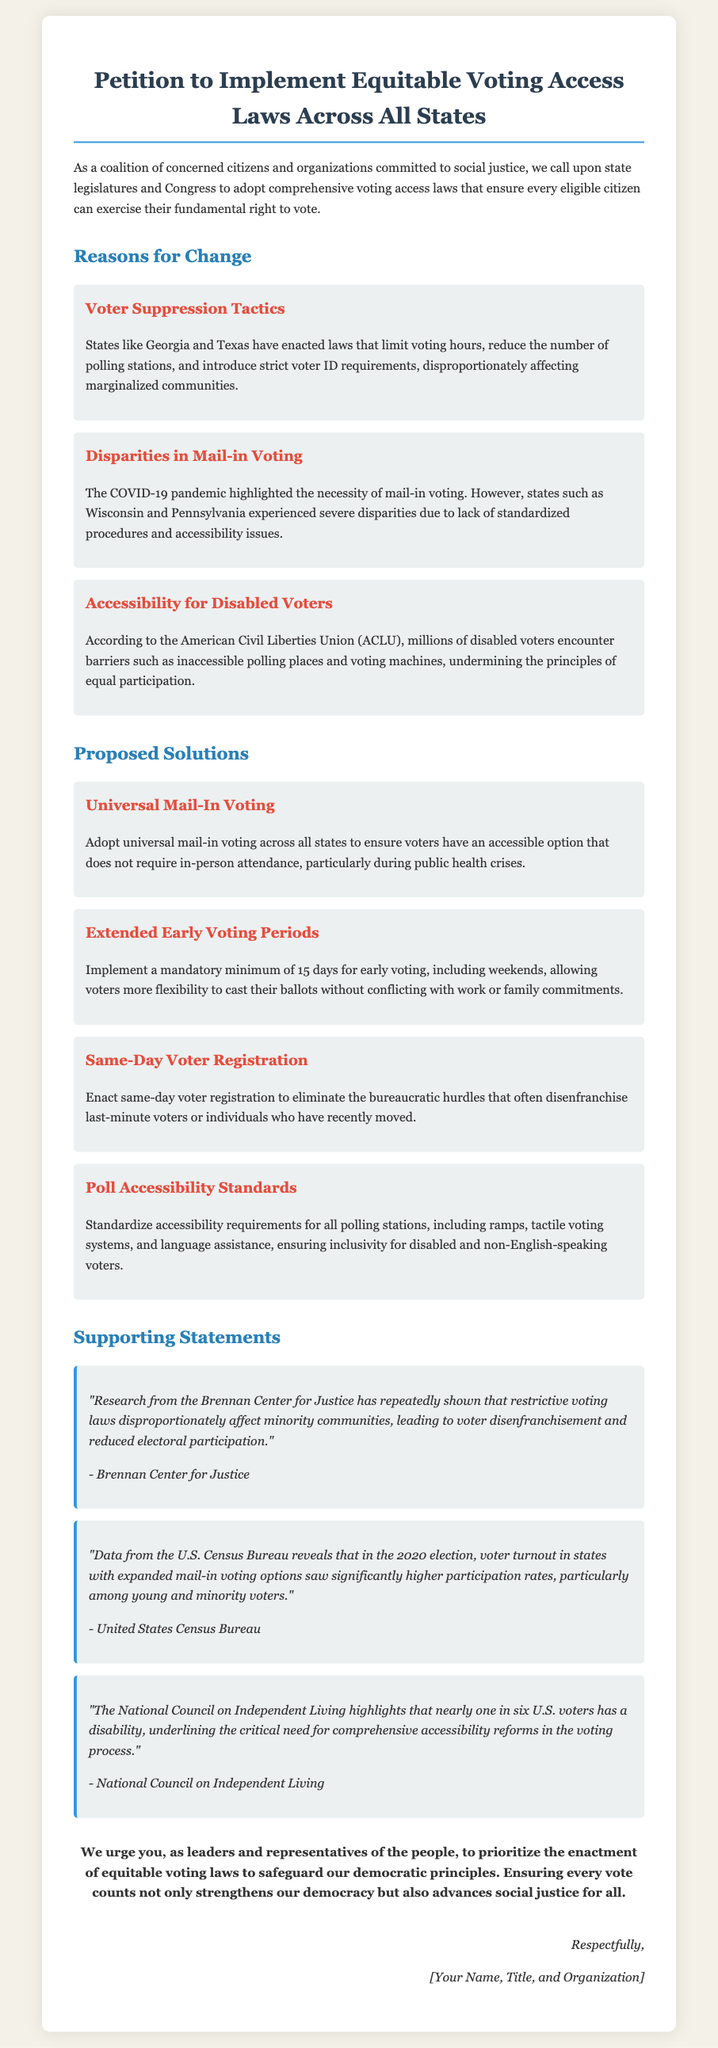What is the title of the petition? The title of the petition is stated at the top of the document, emphasizing the focus on voting access laws.
Answer: Petition to Implement Equitable Voting Access Laws Across All States Who are affected by voter suppression tactics? The document specifies that marginalized communities are disproportionately affected by voter suppression tactics.
Answer: Marginalized communities How many days for early voting are proposed? The document mentions that a mandatory minimum of 15 days for early voting is proposed.
Answer: 15 days Which organization highlights the need for comprehensive accessibility reforms? The document cites the National Council on Independent Living as highlighting this need.
Answer: National Council on Independent Living What is one proposed solution for mail-in voting? The document proposes universal mail-in voting as one of the solutions for improving voting access.
Answer: Universal mail-in voting What problem does the COVID-19 pandemic illustrate in voting? The document indicates that the pandemic highlighted the necessity of mail-in voting.
Answer: Necessity of mail-in voting What statement supports the impact of restrictive voting laws? The Brennan Center for Justice statement supports the argument regarding the impact of restrictive voting laws.
Answer: "Research from the Brennan Center for Justice has repeatedly shown that restrictive voting laws disproportionately affect minority communities, leading to voter disenfranchisement and reduced electoral participation." What is the significance of increased mail-in voting options? The document refers to U.S. Census Bureau data showing higher participation rates among young and minority voters due to expanded mail-in voting options.
Answer: Higher participation rates What does the petition urge leaders to enact? The petition urges leaders and representatives to prioritize the enactment of equitable voting laws.
Answer: Equitable voting laws 